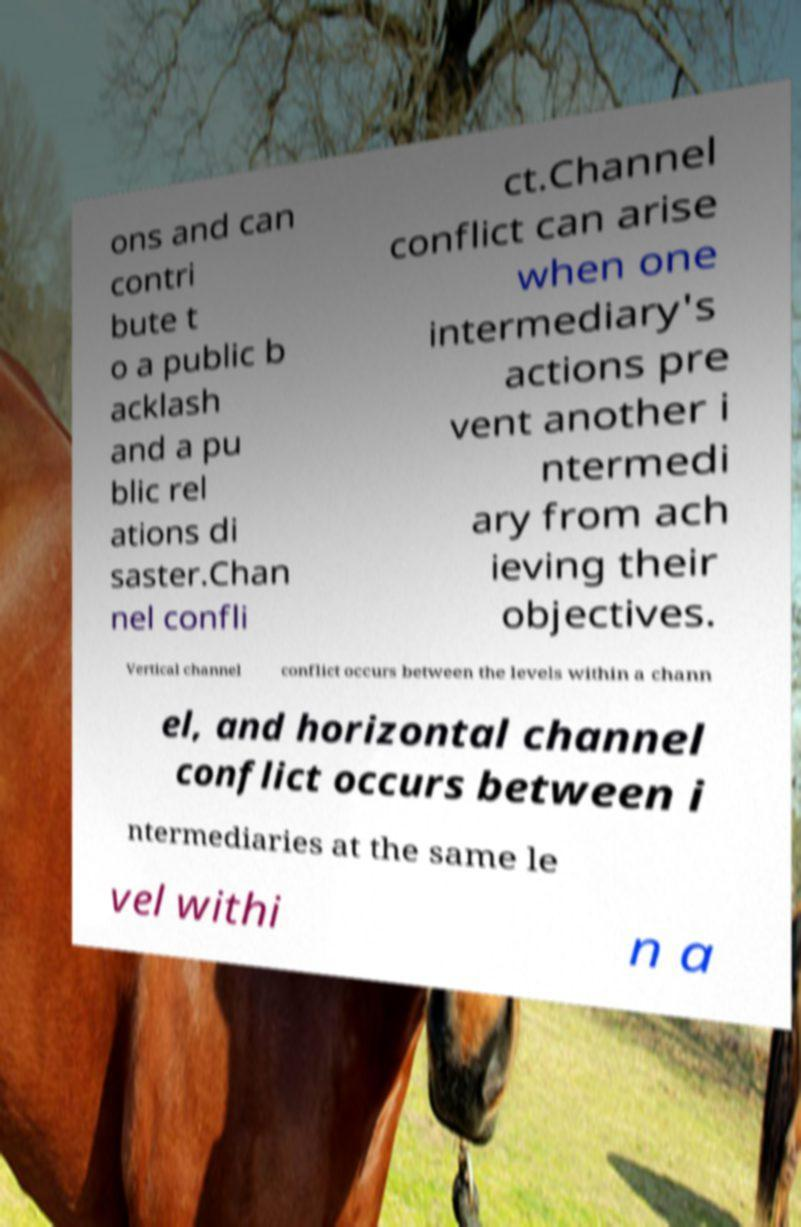What messages or text are displayed in this image? I need them in a readable, typed format. ons and can contri bute t o a public b acklash and a pu blic rel ations di saster.Chan nel confli ct.Channel conflict can arise when one intermediary's actions pre vent another i ntermedi ary from ach ieving their objectives. Vertical channel conflict occurs between the levels within a chann el, and horizontal channel conflict occurs between i ntermediaries at the same le vel withi n a 